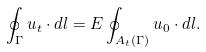<formula> <loc_0><loc_0><loc_500><loc_500>\oint _ { \Gamma } u _ { t } \cdot d l = E \oint _ { A _ { t } ( \Gamma ) } u _ { 0 } \cdot d l .</formula> 